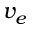Convert formula to latex. <formula><loc_0><loc_0><loc_500><loc_500>v _ { e }</formula> 